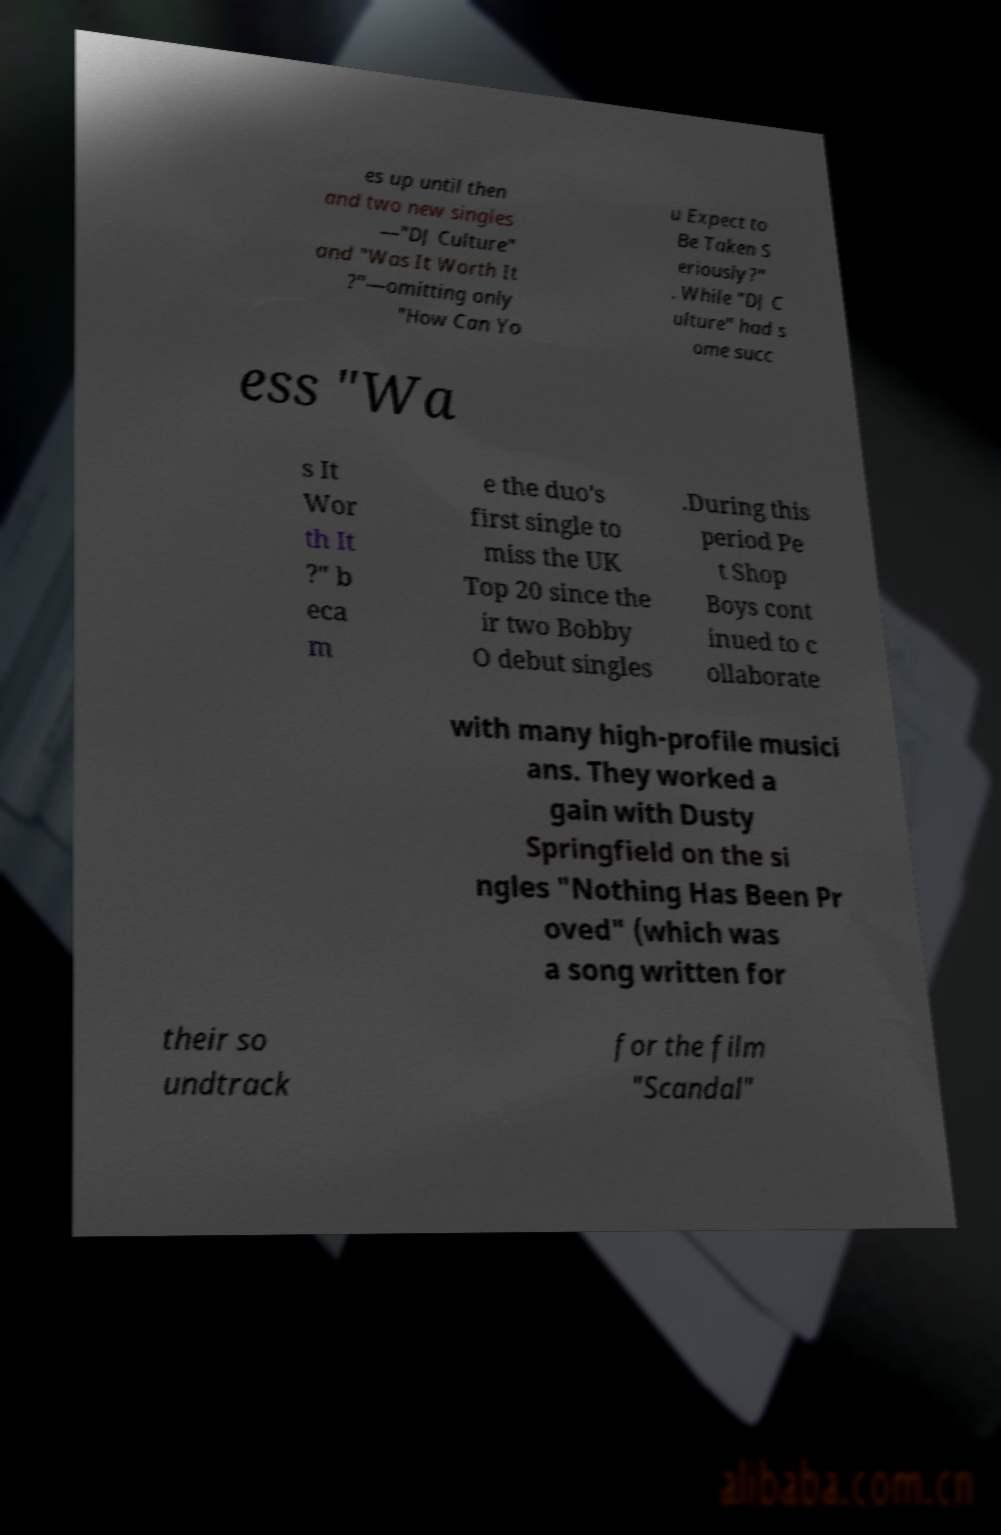Please read and relay the text visible in this image. What does it say? es up until then and two new singles —"DJ Culture" and "Was It Worth It ?"—omitting only "How Can Yo u Expect to Be Taken S eriously?" . While "DJ C ulture" had s ome succ ess "Wa s It Wor th It ?" b eca m e the duo's first single to miss the UK Top 20 since the ir two Bobby O debut singles .During this period Pe t Shop Boys cont inued to c ollaborate with many high-profile musici ans. They worked a gain with Dusty Springfield on the si ngles "Nothing Has Been Pr oved" (which was a song written for their so undtrack for the film "Scandal" 